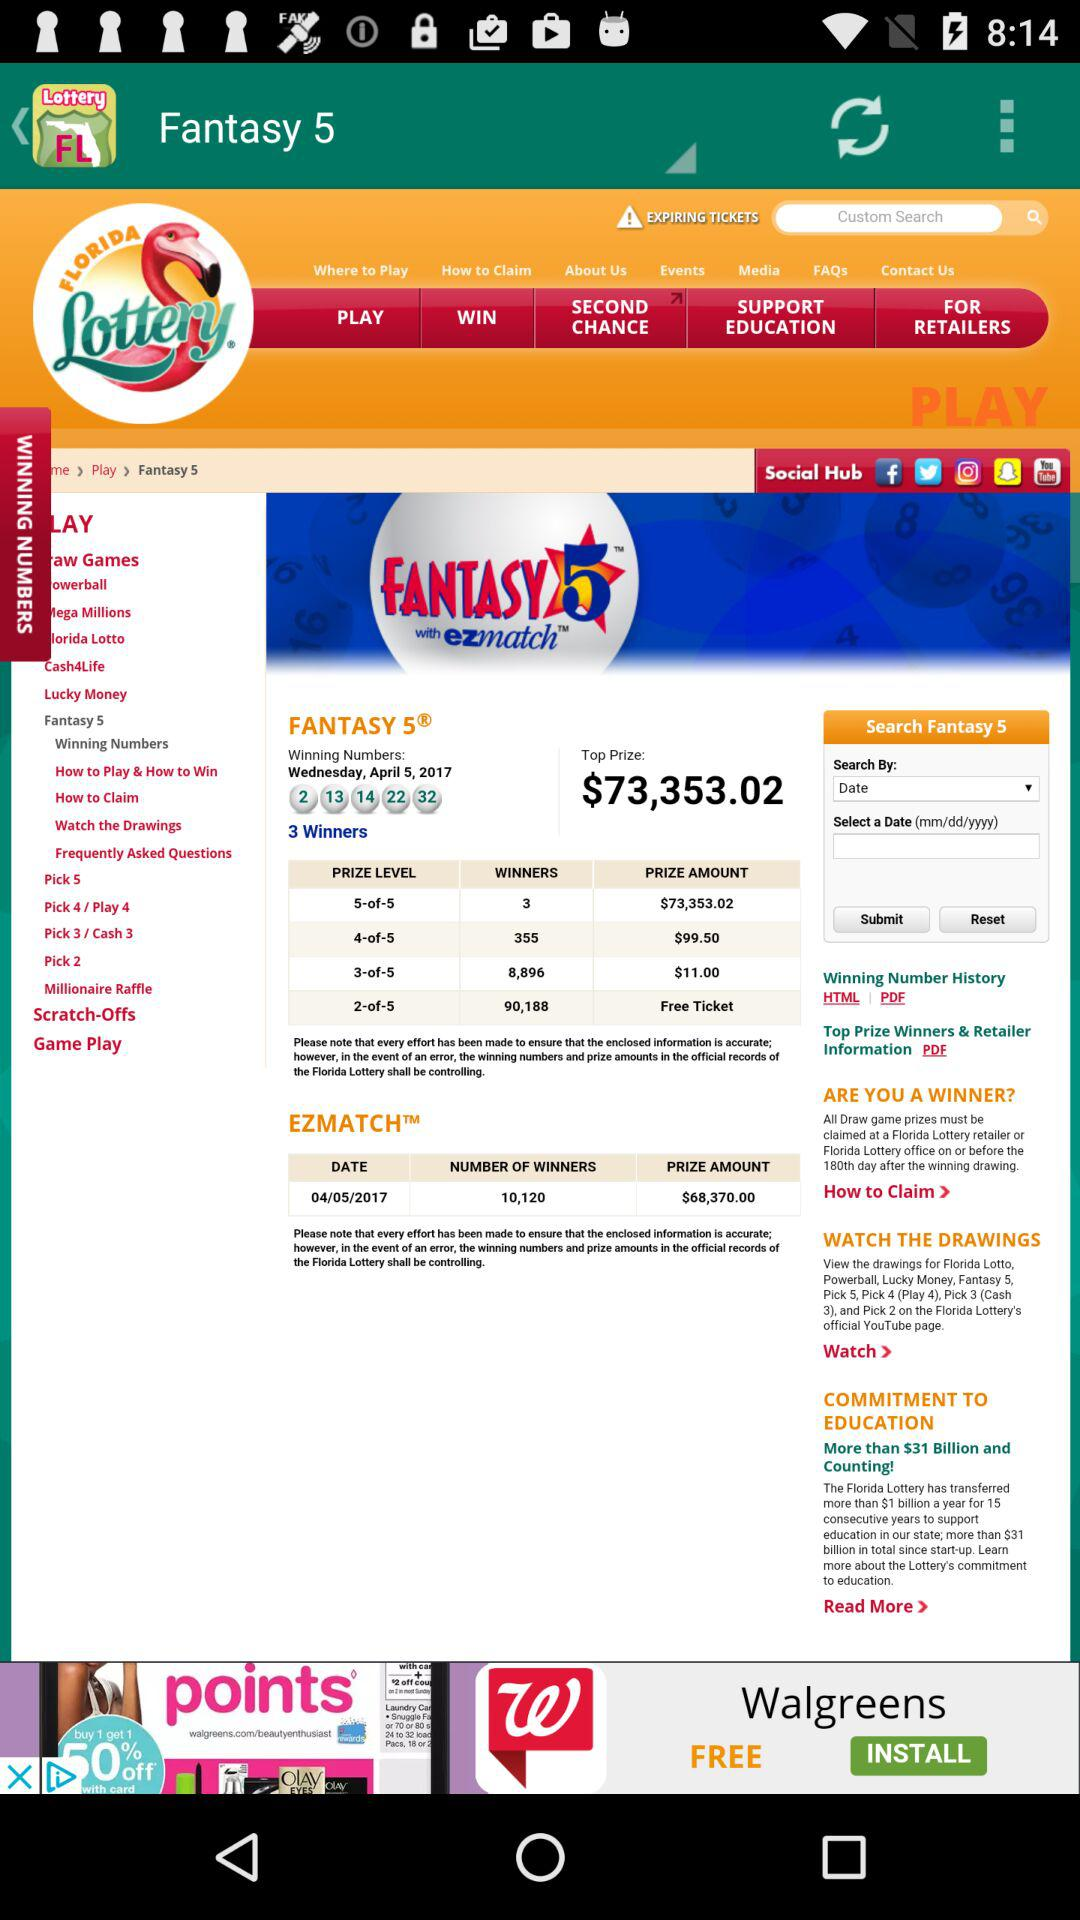What date is mentioned for "EZMATCH"? The mentioned date is April 5, 2017. 